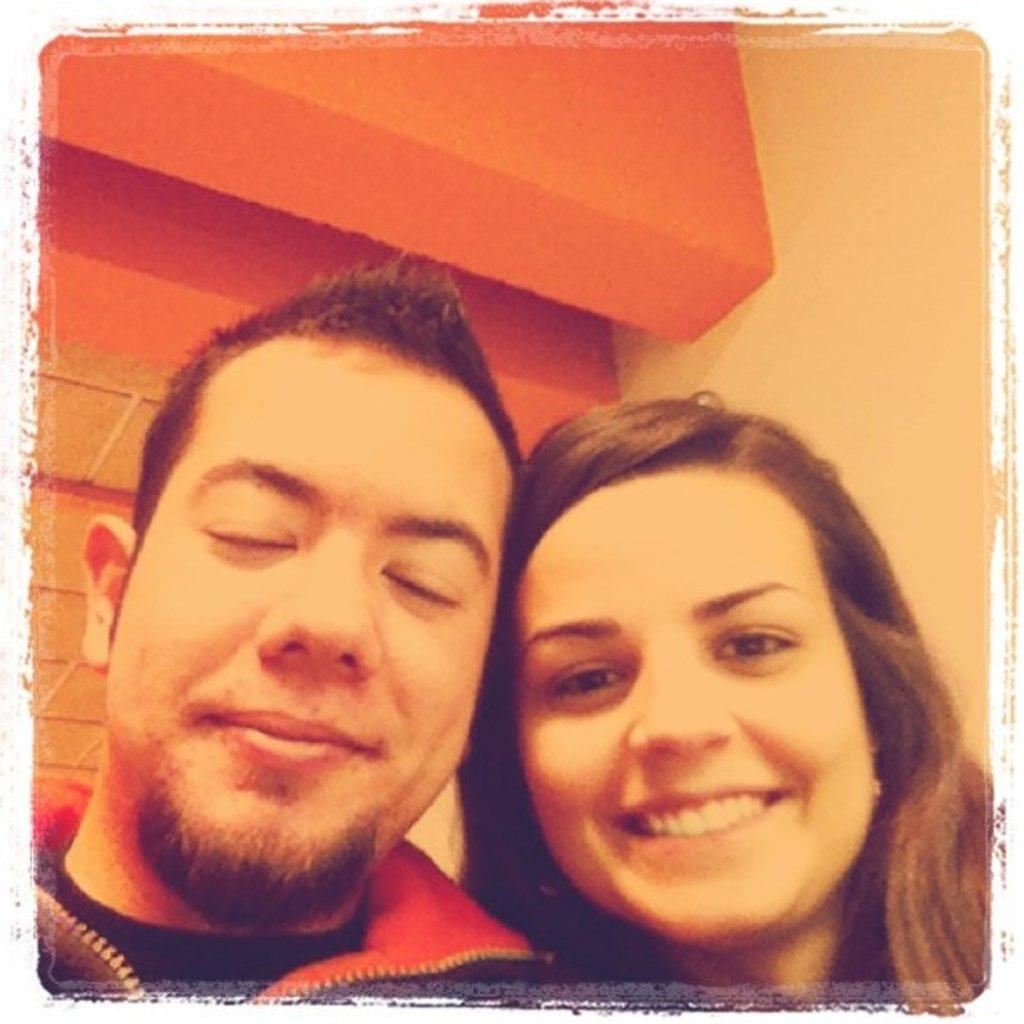How many people are present in the image? There are two people in the image, a man and a woman. Where are the man and the woman located in the image? Both the man and the woman are in the foreground of the image. What color are the eyes of the volleyball in the image? There is no volleyball present in the image, so it is not possible to determine the color of its eyes. 